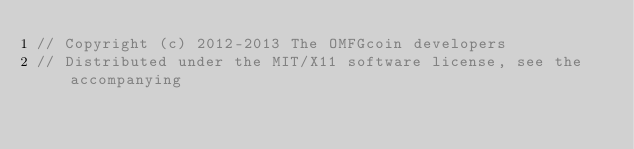<code> <loc_0><loc_0><loc_500><loc_500><_C++_>// Copyright (c) 2012-2013 The OMFGcoin developers
// Distributed under the MIT/X11 software license, see the accompanying</code> 